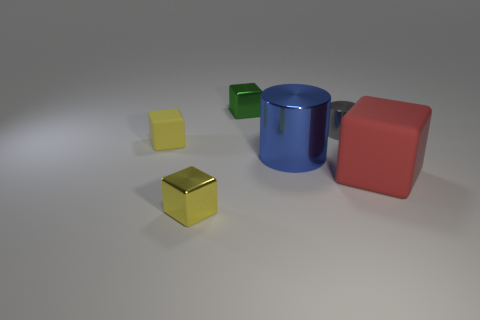There is a metallic thing that is behind the gray cylinder; does it have the same size as the yellow shiny thing?
Offer a very short reply. Yes. There is a yellow block that is in front of the tiny rubber block; what is it made of?
Your answer should be very brief. Metal. Is the number of things greater than the number of big blue cylinders?
Make the answer very short. Yes. How many things are either tiny blocks behind the big red object or small green blocks?
Ensure brevity in your answer.  2. What number of small green cubes are behind the metallic cube that is left of the small green metal block?
Ensure brevity in your answer.  1. What is the size of the block that is in front of the rubber thing on the right side of the tiny thing in front of the tiny yellow rubber object?
Ensure brevity in your answer.  Small. There is a shiny block that is in front of the tiny green thing; does it have the same color as the small metallic cylinder?
Your answer should be very brief. No. What is the size of the red thing that is the same shape as the green shiny thing?
Your answer should be very brief. Large. How many things are either small objects in front of the blue cylinder or cubes in front of the green object?
Make the answer very short. 3. What shape is the rubber object that is on the left side of the metallic cube in front of the small gray metal cylinder?
Give a very brief answer. Cube. 